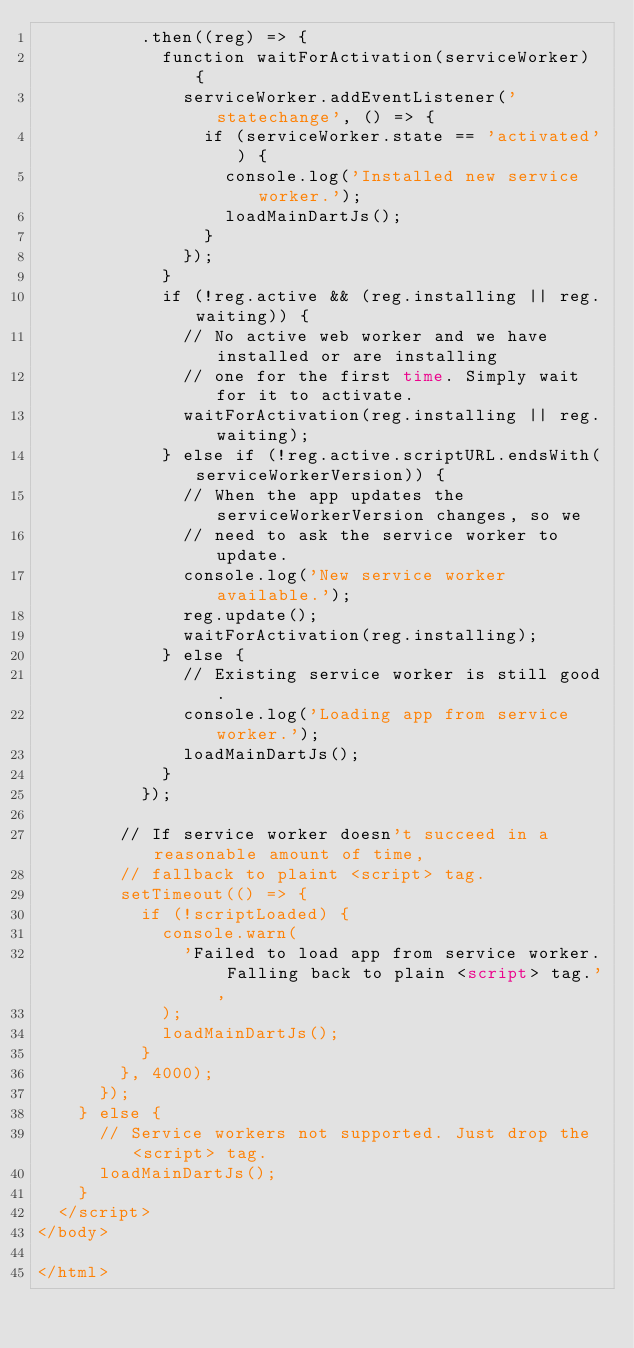<code> <loc_0><loc_0><loc_500><loc_500><_HTML_>          .then((reg) => {
            function waitForActivation(serviceWorker) {
              serviceWorker.addEventListener('statechange', () => {
                if (serviceWorker.state == 'activated') {
                  console.log('Installed new service worker.');
                  loadMainDartJs();
                }
              });
            }
            if (!reg.active && (reg.installing || reg.waiting)) {
              // No active web worker and we have installed or are installing
              // one for the first time. Simply wait for it to activate.
              waitForActivation(reg.installing || reg.waiting);
            } else if (!reg.active.scriptURL.endsWith(serviceWorkerVersion)) {
              // When the app updates the serviceWorkerVersion changes, so we
              // need to ask the service worker to update.
              console.log('New service worker available.');
              reg.update();
              waitForActivation(reg.installing);
            } else {
              // Existing service worker is still good.
              console.log('Loading app from service worker.');
              loadMainDartJs();
            }
          });

        // If service worker doesn't succeed in a reasonable amount of time,
        // fallback to plaint <script> tag.
        setTimeout(() => {
          if (!scriptLoaded) {
            console.warn(
              'Failed to load app from service worker. Falling back to plain <script> tag.',
            );
            loadMainDartJs();
          }
        }, 4000);
      });
    } else {
      // Service workers not supported. Just drop the <script> tag.
      loadMainDartJs();
    }
  </script>
</body>

</html></code> 